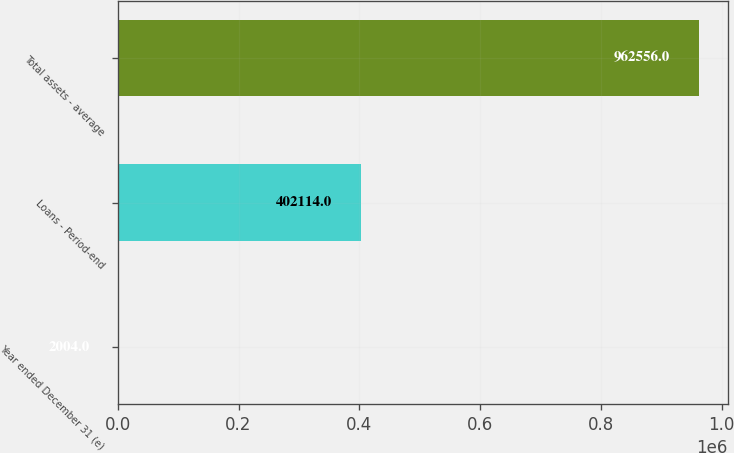Convert chart to OTSL. <chart><loc_0><loc_0><loc_500><loc_500><bar_chart><fcel>Year ended December 31 (e)<fcel>Loans - Period-end<fcel>Total assets - average<nl><fcel>2004<fcel>402114<fcel>962556<nl></chart> 